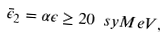Convert formula to latex. <formula><loc_0><loc_0><loc_500><loc_500>\bar { \epsilon } _ { 2 } = \alpha \epsilon \geq 2 0 { \ s y { M e V } } ,</formula> 